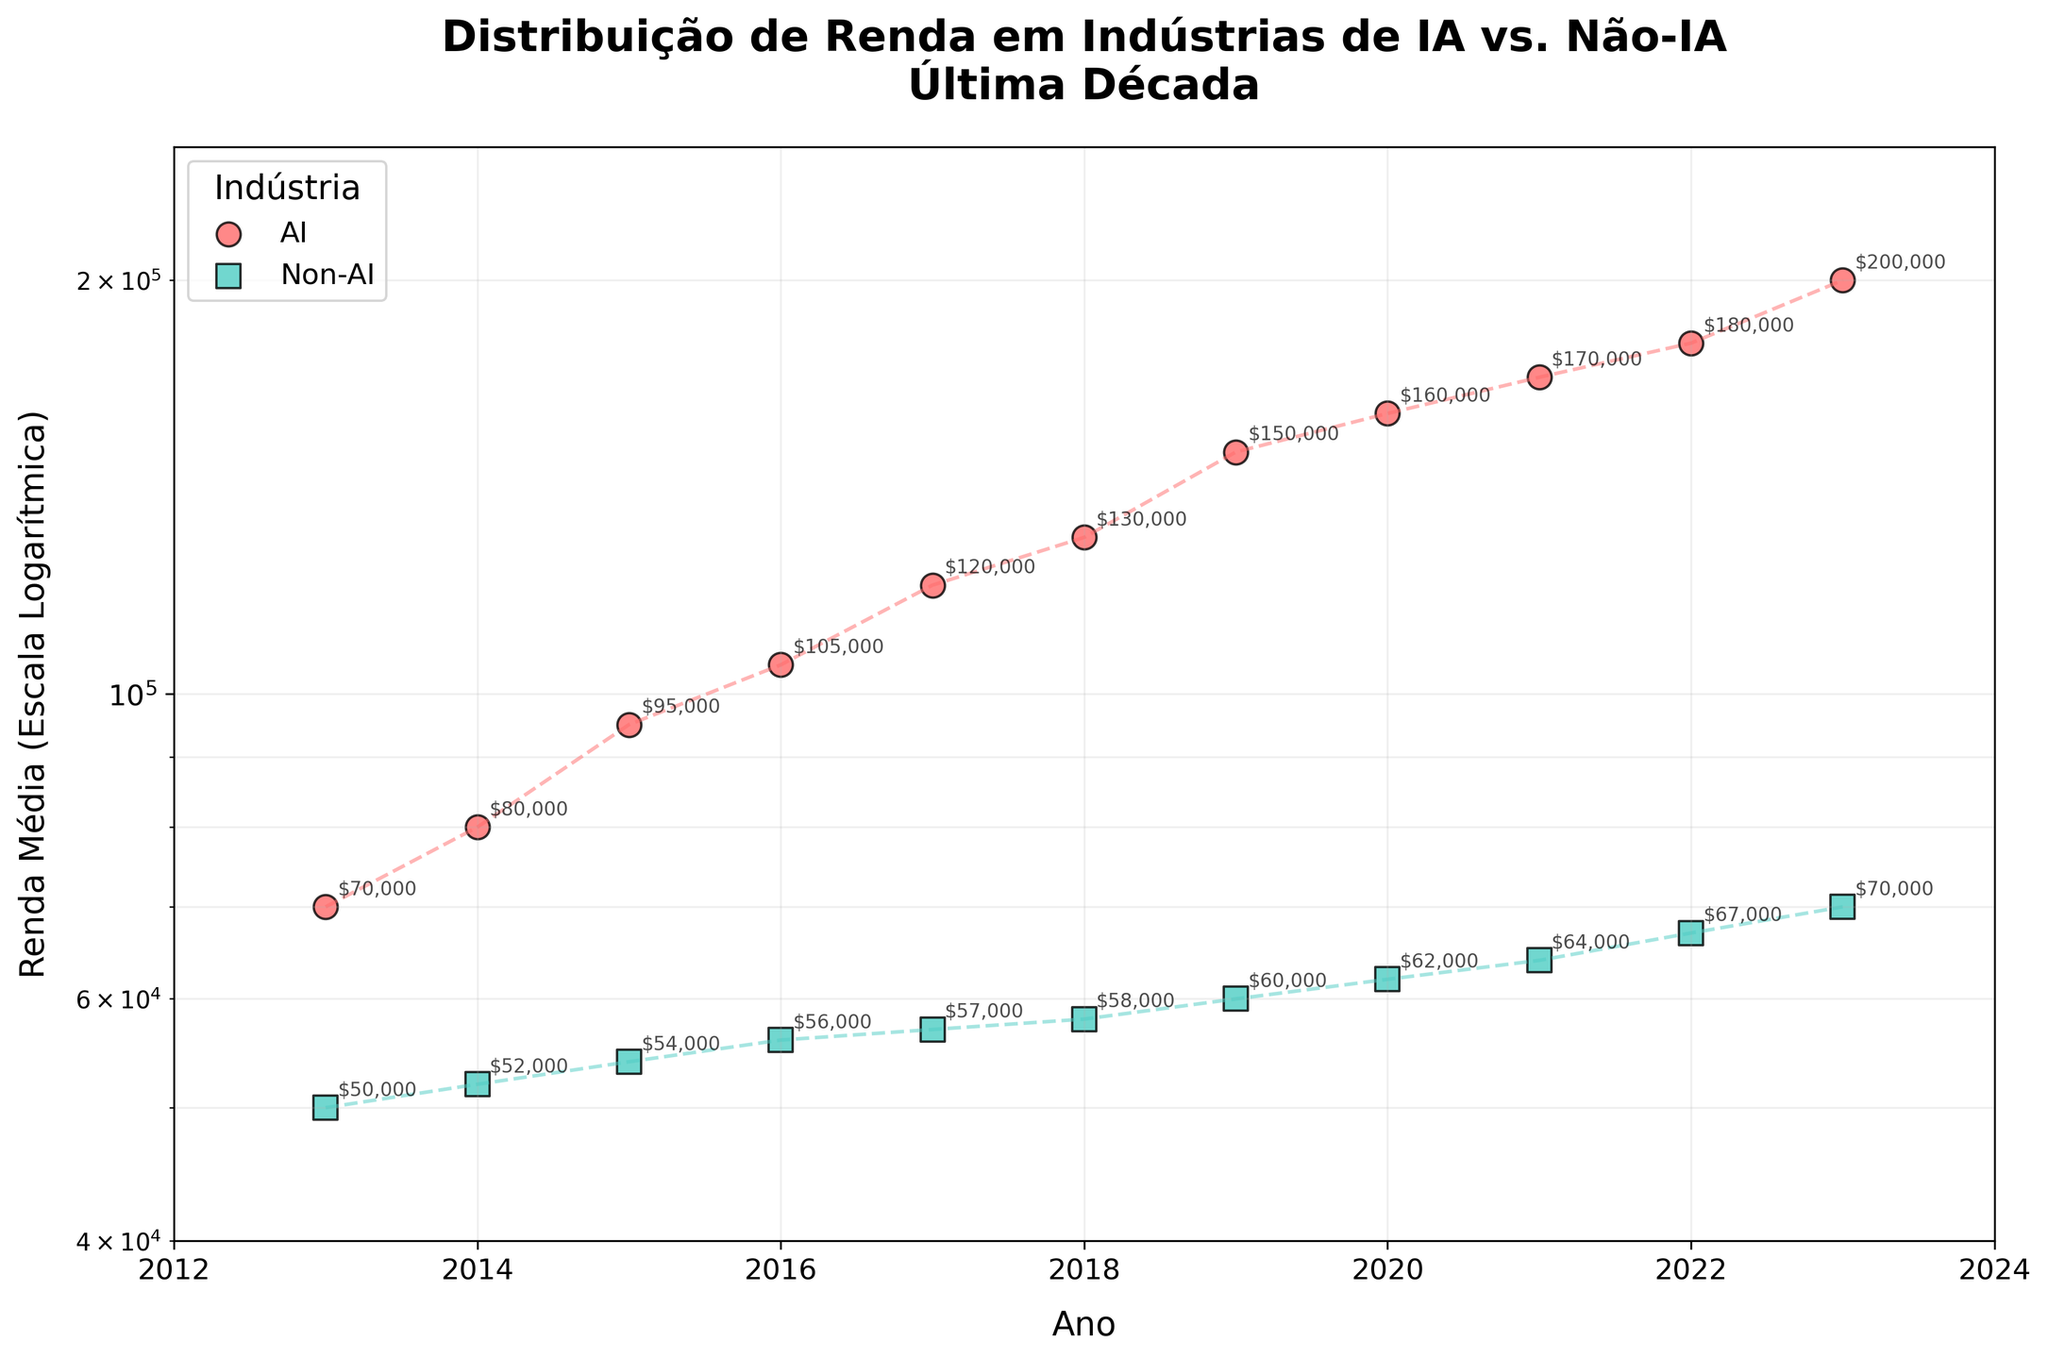What is the title of the scatter plot? The scatter plot title is clearly written at the top of the figure. It reads "Distribuição de Renda em Indústrias de IA vs. Não-IA\nÚltima Década", indicating that the plot shows the income distribution among AI and non-AI industries over the last decade.
Answer: Distribuição de Renda em Indústrias de IA vs. Não-IA Última Década What is the minimum income shown for AI industries? To find the minimum income for AI industries, look for the lowest y-value among the AI industry data points. The earliest data point for AI in 2013 indicates an income of $70,000.
Answer: $70,000 Between which years do we see the maximum difference in average income for the AI industry? To determine the maximum difference, calculate the yearly increases in average income for the AI industry. The largest increment occurs between 2022 and 2023, where the income rose from $180,000 to $200,000, an increase of $20,000.
Answer: 2022 and 2023 How do the average incomes of AI and Non-AI industries compare in the year 2023? To compare the incomes for the year 2023, locate the y-values for both industries in that year. The AI industry's income is $200,000, while the Non-AI industry's income is $70,000. Thus, the AI industry's income is significantly higher.
Answer: AI: $200,000, Non-AI: $70,000 What trend can be observed in the income of AI industries from 2013 to 2023? To observe trends, follow the trajectory of the data points for AI industries over time. From 2013 to 2023, there is a consistent increase in average income, indicating growth in the AI sector over the decade.
Answer: Increasing trend How does the growth rate of AI industry income compare to that of Non-AI industries over the decade? Examine the overall growth from 2013 to 2023 for both industries. The AI industry's income grows from $70,000 to $200,000, an increase of approximately 186%. The Non-AI industry grows from $50,000 to $70,000, an increase of 40%. Thus, the AI industry has a much higher growth rate.
Answer: AI: 186%, Non-AI: 40% Which industry shows a generally steeper increase in income on the log scale from 2013 to 2023? On a logarithmic scale, steeper increases correspond to larger multiplicative changes. The AI industry's income visibly increases more sharply, indicating it has a steeper growth compared to the Non-AI industry, which rises more gradually.
Answer: AI industry What is the overall percentage increase in income for the Non-AI industry from 2013 to 2023? Calculate the percentage increase using the formula: ((final value - initial value) / initial value) * 100. For the Non-AI industry: ((70,000 - 50,000) / 50,000) * 100 = 40%.
Answer: 40% What can be inferred about the disparity in income between AI and Non-AI industries by the end of the decade? The significant rise in AI industry income compared to the relatively modest increase in Non-AI industry income suggests growing income disparity. By 2023, AI industry incomes are substantially higher than Non-AI incomes, indicating a widening gap.
Answer: Widening income disparity 